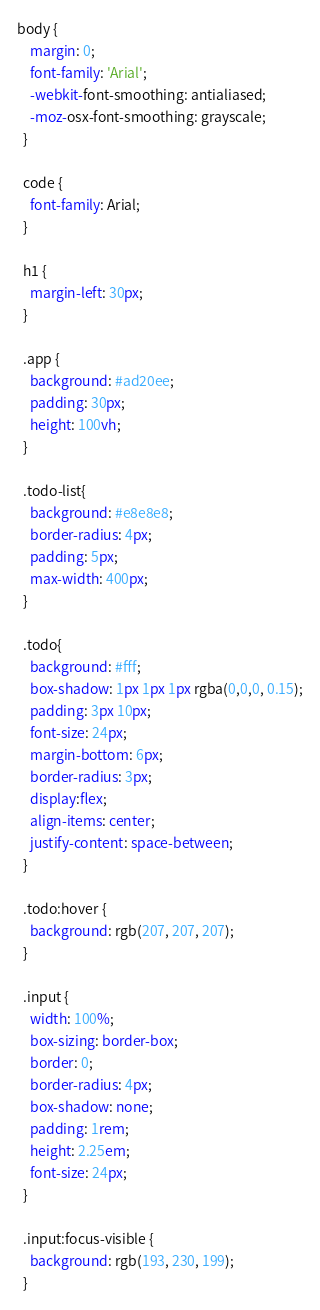<code> <loc_0><loc_0><loc_500><loc_500><_CSS_>body {
    margin: 0;
    font-family: 'Arial';
    -webkit-font-smoothing: antialiased;
    -moz-osx-font-smoothing: grayscale;
  }
  
  code {
    font-family: Arial;
  }
  
  h1 {
    margin-left: 30px;
  }
  
  .app {
    background: #ad20ee;
    padding: 30px;
    height: 100vh;
  }
  
  .todo-list{
    background: #e8e8e8;
    border-radius: 4px;
    padding: 5px;
    max-width: 400px;
  }
  
  .todo{
    background: #fff;
    box-shadow: 1px 1px 1px rgba(0,0,0, 0.15);
    padding: 3px 10px;
    font-size: 24px;
    margin-bottom: 6px;
    border-radius: 3px;
    display:flex;
    align-items: center;
    justify-content: space-between;
  }
  
  .todo:hover {
    background: rgb(207, 207, 207);
  }
  
  .input {
    width: 100%;
    box-sizing: border-box;
    border: 0;
    border-radius: 4px;
    box-shadow: none;
    padding: 1rem;
    height: 2.25em;
    font-size: 24px;
  }
  
  .input:focus-visible {
    background: rgb(193, 230, 199);
  }</code> 